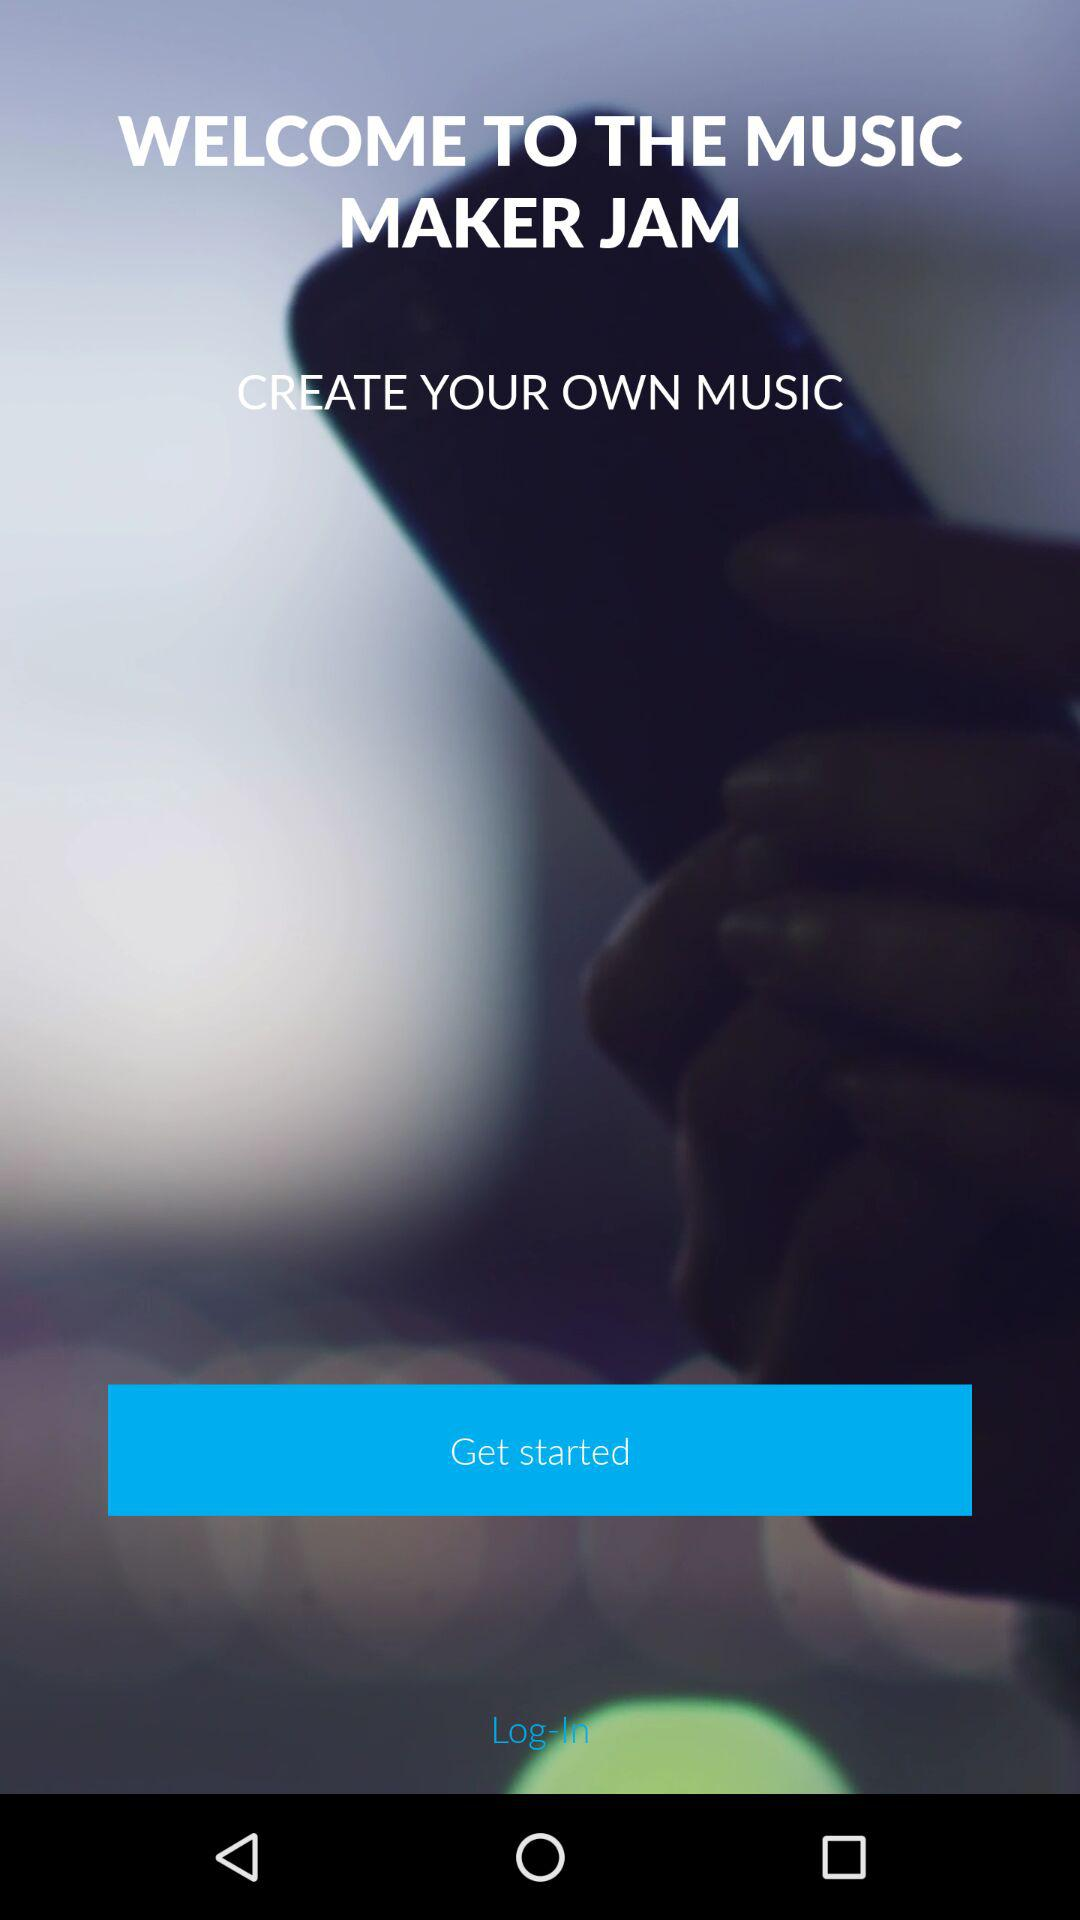What is the name of the application? The name of the application is "MUSIC MAKER JAM". 